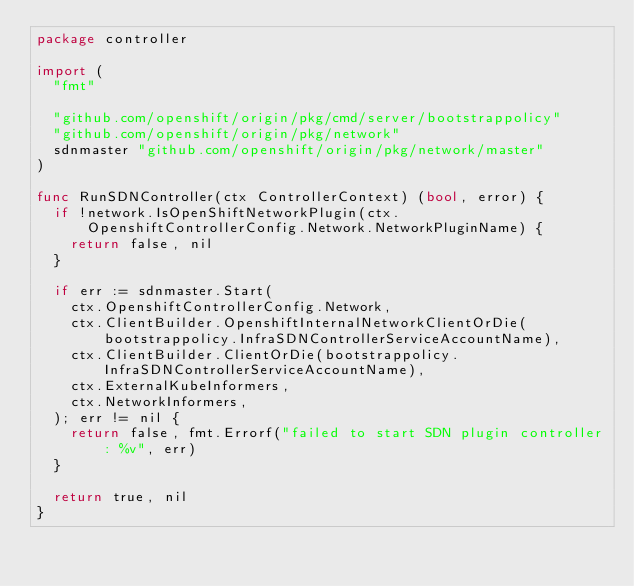<code> <loc_0><loc_0><loc_500><loc_500><_Go_>package controller

import (
	"fmt"

	"github.com/openshift/origin/pkg/cmd/server/bootstrappolicy"
	"github.com/openshift/origin/pkg/network"
	sdnmaster "github.com/openshift/origin/pkg/network/master"
)

func RunSDNController(ctx ControllerContext) (bool, error) {
	if !network.IsOpenShiftNetworkPlugin(ctx.OpenshiftControllerConfig.Network.NetworkPluginName) {
		return false, nil
	}

	if err := sdnmaster.Start(
		ctx.OpenshiftControllerConfig.Network,
		ctx.ClientBuilder.OpenshiftInternalNetworkClientOrDie(bootstrappolicy.InfraSDNControllerServiceAccountName),
		ctx.ClientBuilder.ClientOrDie(bootstrappolicy.InfraSDNControllerServiceAccountName),
		ctx.ExternalKubeInformers,
		ctx.NetworkInformers,
	); err != nil {
		return false, fmt.Errorf("failed to start SDN plugin controller: %v", err)
	}

	return true, nil
}
</code> 